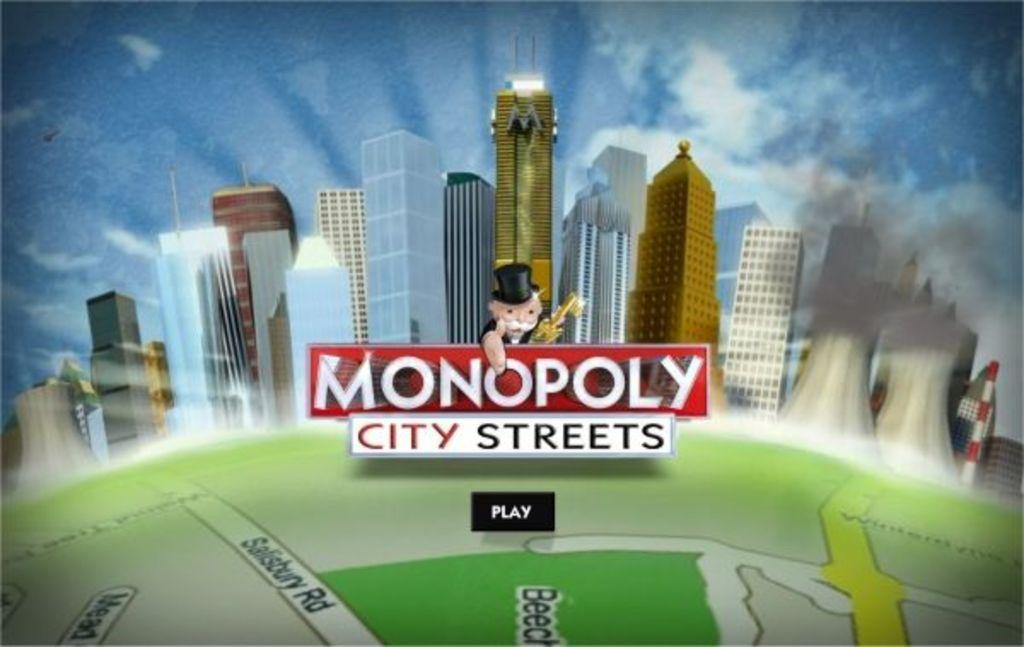<image>
Create a compact narrative representing the image presented. The front of a game box which shows a city vista and the monopoly money man who points to the words City Streets below him. 